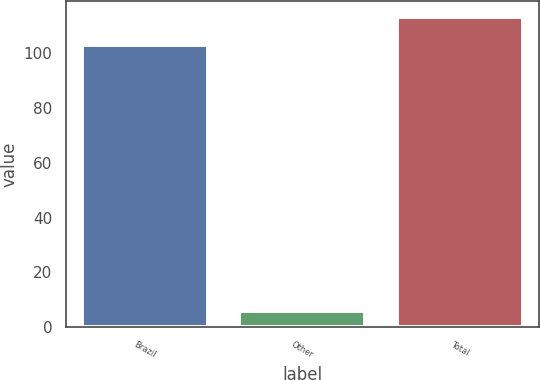Convert chart to OTSL. <chart><loc_0><loc_0><loc_500><loc_500><bar_chart><fcel>Brazil<fcel>Other<fcel>Total<nl><fcel>103<fcel>6<fcel>113.3<nl></chart> 